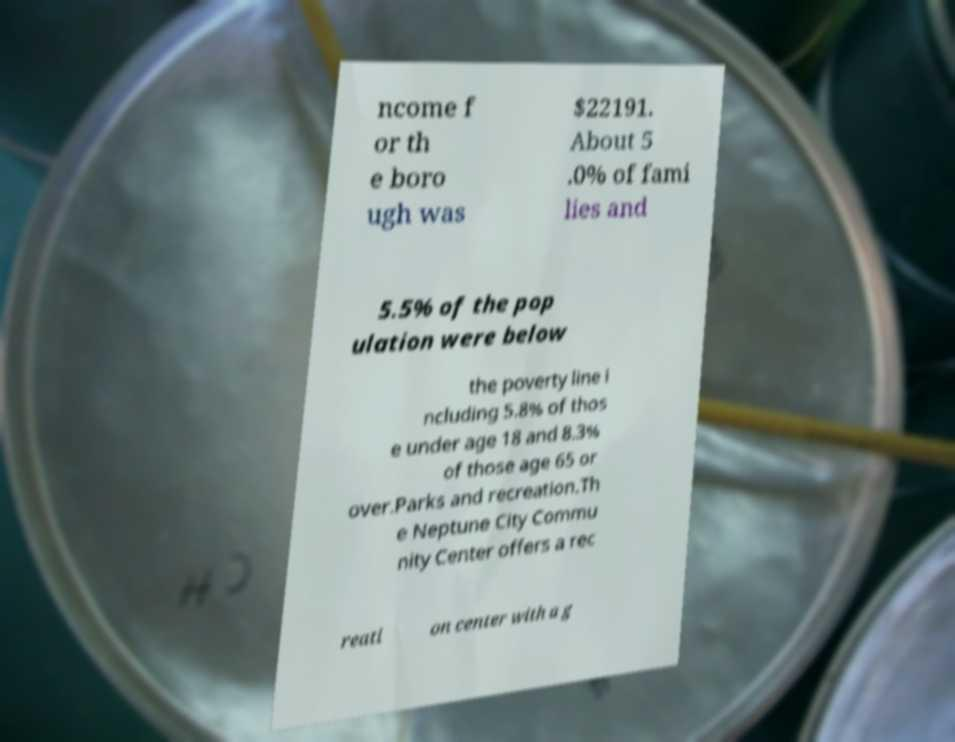Could you assist in decoding the text presented in this image and type it out clearly? ncome f or th e boro ugh was $22191. About 5 .0% of fami lies and 5.5% of the pop ulation were below the poverty line i ncluding 5.8% of thos e under age 18 and 8.3% of those age 65 or over.Parks and recreation.Th e Neptune City Commu nity Center offers a rec reati on center with a g 